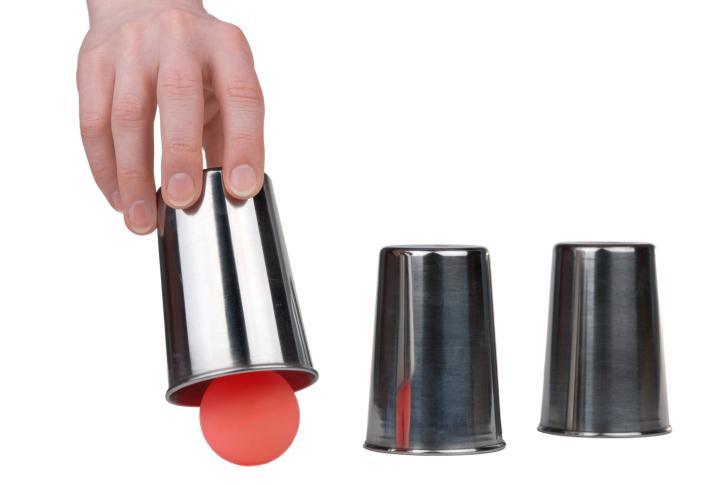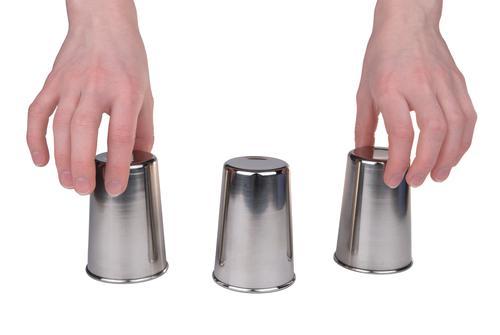The first image is the image on the left, the second image is the image on the right. Examine the images to the left and right. Is the description "There is no more than one red ball." accurate? Answer yes or no. Yes. 